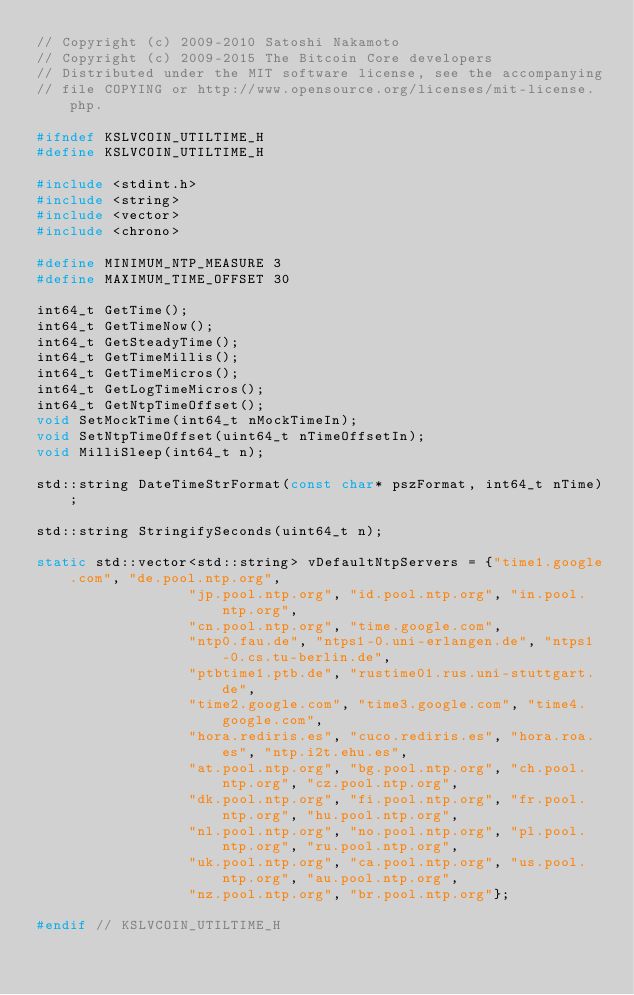<code> <loc_0><loc_0><loc_500><loc_500><_C_>// Copyright (c) 2009-2010 Satoshi Nakamoto
// Copyright (c) 2009-2015 The Bitcoin Core developers
// Distributed under the MIT software license, see the accompanying
// file COPYING or http://www.opensource.org/licenses/mit-license.php.

#ifndef KSLVCOIN_UTILTIME_H
#define KSLVCOIN_UTILTIME_H

#include <stdint.h>
#include <string>
#include <vector>
#include <chrono>

#define MINIMUM_NTP_MEASURE 3
#define MAXIMUM_TIME_OFFSET 30

int64_t GetTime();
int64_t GetTimeNow();
int64_t GetSteadyTime();
int64_t GetTimeMillis();
int64_t GetTimeMicros();
int64_t GetLogTimeMicros();
int64_t GetNtpTimeOffset();
void SetMockTime(int64_t nMockTimeIn);
void SetNtpTimeOffset(uint64_t nTimeOffsetIn);
void MilliSleep(int64_t n);

std::string DateTimeStrFormat(const char* pszFormat, int64_t nTime);

std::string StringifySeconds(uint64_t n);

static std::vector<std::string> vDefaultNtpServers = {"time1.google.com", "de.pool.ntp.org",
                  "jp.pool.ntp.org", "id.pool.ntp.org", "in.pool.ntp.org",
                  "cn.pool.ntp.org", "time.google.com",
                  "ntp0.fau.de", "ntps1-0.uni-erlangen.de", "ntps1-0.cs.tu-berlin.de",
                  "ptbtime1.ptb.de", "rustime01.rus.uni-stuttgart.de",
                  "time2.google.com", "time3.google.com", "time4.google.com",
                  "hora.rediris.es", "cuco.rediris.es", "hora.roa.es", "ntp.i2t.ehu.es",
                  "at.pool.ntp.org", "bg.pool.ntp.org", "ch.pool.ntp.org", "cz.pool.ntp.org",
                  "dk.pool.ntp.org", "fi.pool.ntp.org", "fr.pool.ntp.org", "hu.pool.ntp.org",
                  "nl.pool.ntp.org", "no.pool.ntp.org", "pl.pool.ntp.org", "ru.pool.ntp.org",
                  "uk.pool.ntp.org", "ca.pool.ntp.org", "us.pool.ntp.org", "au.pool.ntp.org",
                  "nz.pool.ntp.org", "br.pool.ntp.org"};

#endif // KSLVCOIN_UTILTIME_H
</code> 